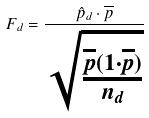<formula> <loc_0><loc_0><loc_500><loc_500>F _ { d } = \frac { \hat { p } _ { d } \cdot \overline { p } } { \sqrt { \frac { \overline { p } ( 1 \cdot \overline { p } ) } { n _ { d } } } }</formula> 